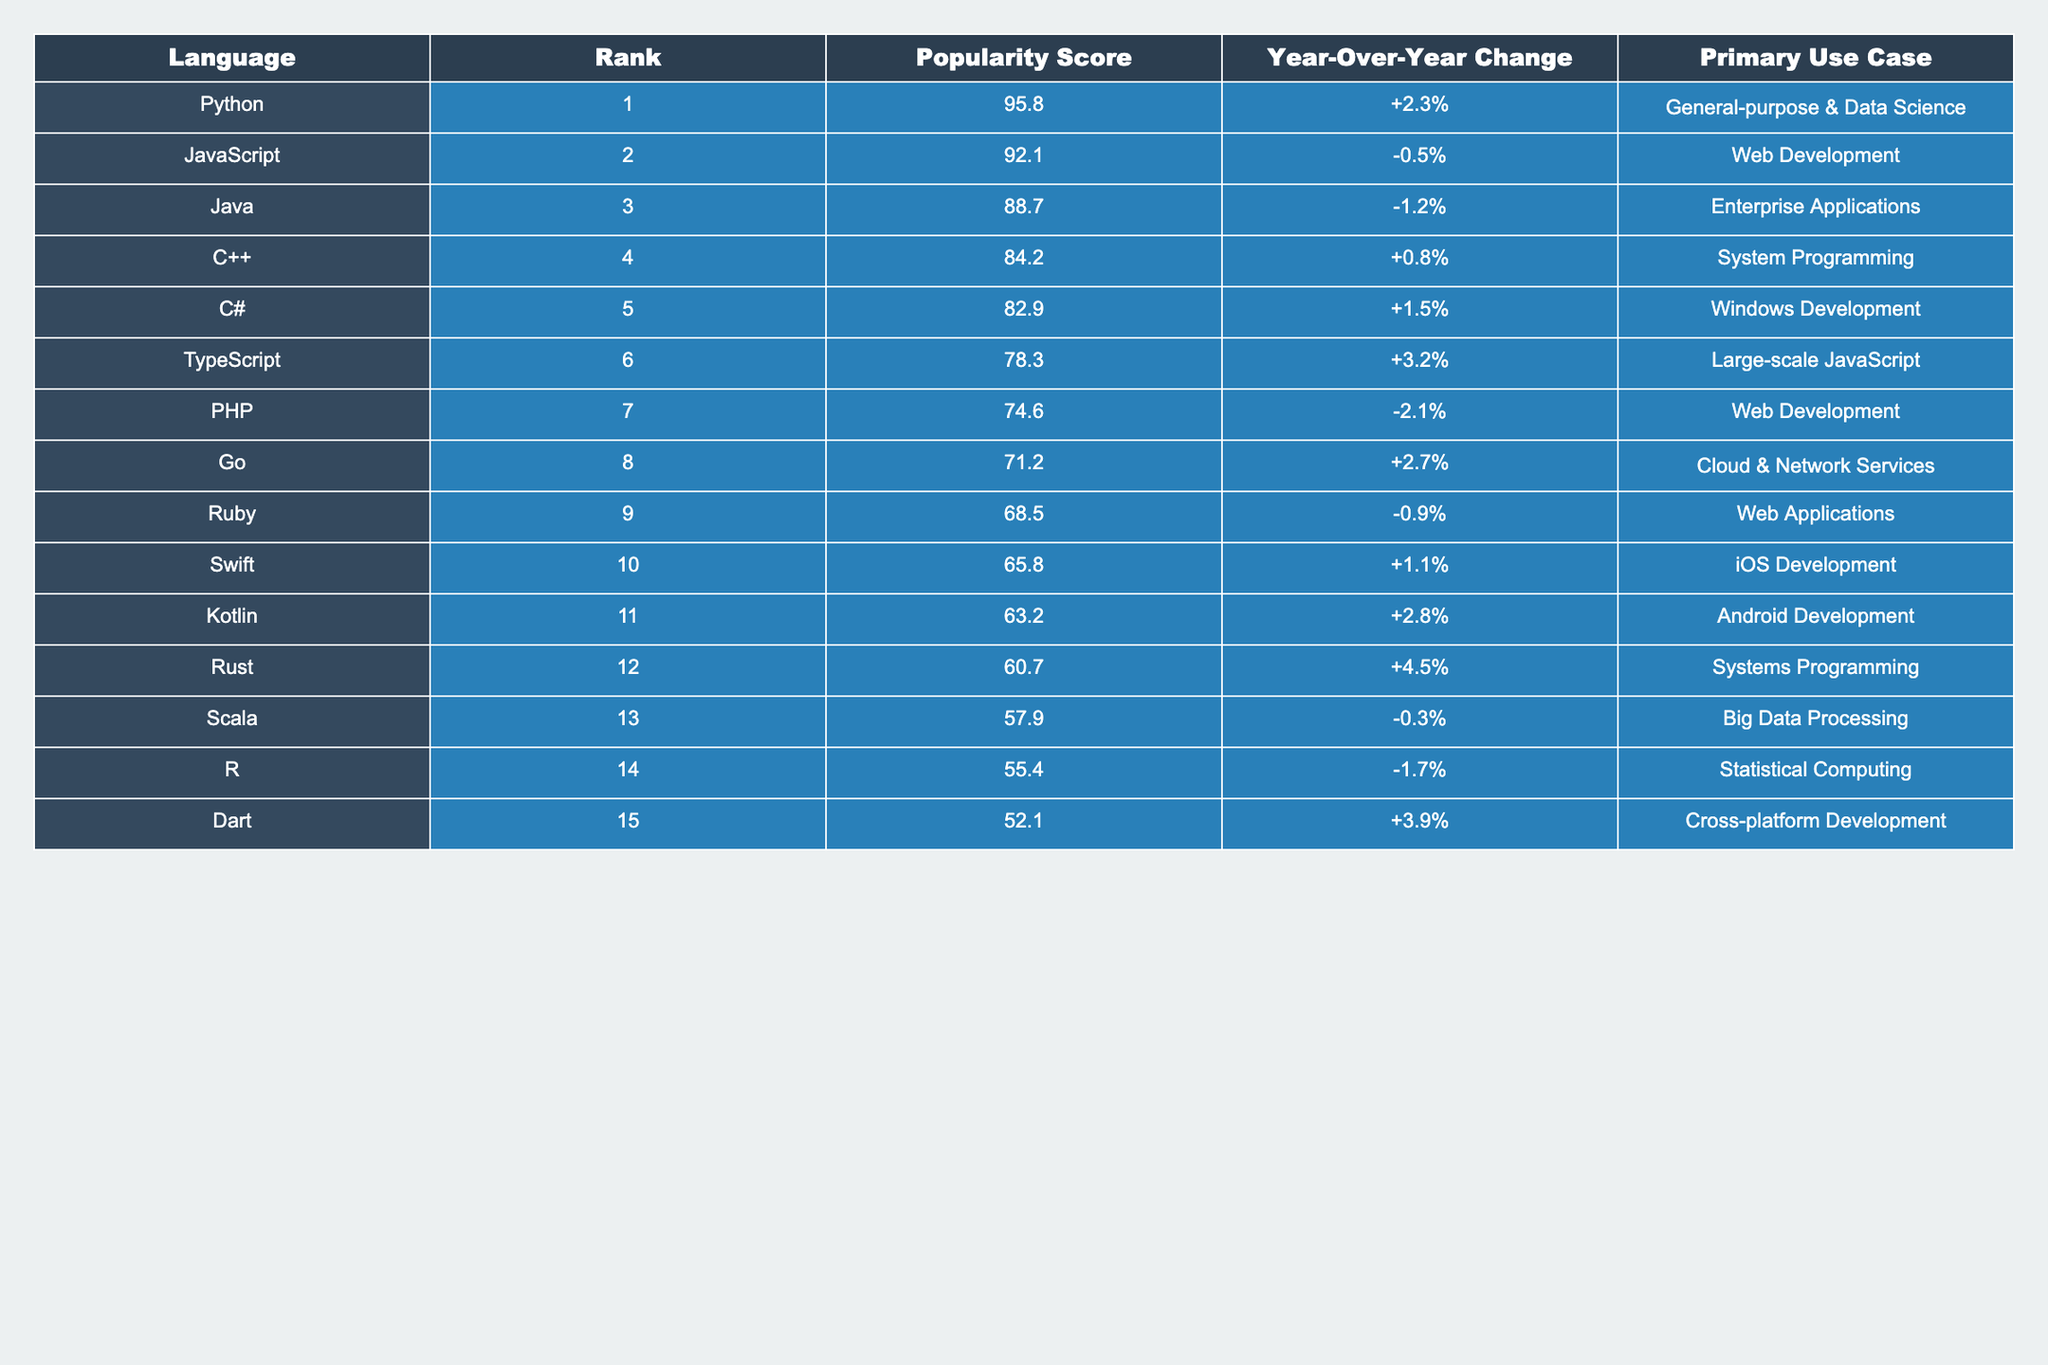What is the most popular programming language in 2023? According to the table, the programming language with the highest popularity score is Python, with a score of 95.8.
Answer: Python Which programming language has a rank of 5? The table indicates that C# is ranked 5th in programming language popularity.
Answer: C# What is the popularity score of Java? The table shows that Java has a popularity score of 88.7.
Answer: 88.7 Which language experienced the highest year-over-year change? Analyzing the year-over-year changes, Rust has the highest increase at +4.5%.
Answer: Rust How many programming languages have a popularity score above 80? Counting the scores above 80 in the table: Python (95.8), JavaScript (92.1), Java (88.7), C++ (84.2), and C# (82.9), there are 5 such languages.
Answer: 5 Is there any programming language that has a negative year-over-year change? Yes, the table lists several languages with negative changes: JavaScript (-0.5%), Java (-1.2%), PHP (-2.1%), R (-1.7%), and Scala (-0.3%).
Answer: Yes What is the difference in popularity score between the top-ranked and bottom-ranked language? The top-ranked language (Python) has a score of 95.8, and the bottom-ranked language (Dart) has a score of 52.1. The difference is 95.8 - 52.1 = 43.7.
Answer: 43.7 What is the average popularity score of the top three programming languages? The scores of the top three languages are 95.8 (Python), 92.1 (JavaScript), and 88.7 (Java). The sum is 95.8 + 92.1 + 88.7 = 276.6. The average is 276.6 / 3 = 92.2.
Answer: 92.2 Which programming language is primarily used for iOS development? From the table, Swift is the programming language assigned to iOS development.
Answer: Swift Is the popularity score of Kotlin higher or lower than 65? The popularity score of Kotlin is 63.2, which is lower than 65.
Answer: Lower 